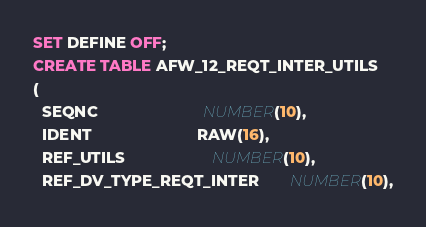<code> <loc_0><loc_0><loc_500><loc_500><_SQL_>SET DEFINE OFF;
CREATE TABLE AFW_12_REQT_INTER_UTILS
(
  SEQNC                        NUMBER(10),
  IDENT                        RAW(16),
  REF_UTILS                    NUMBER(10),
  REF_DV_TYPE_REQT_INTER       NUMBER(10),</code> 